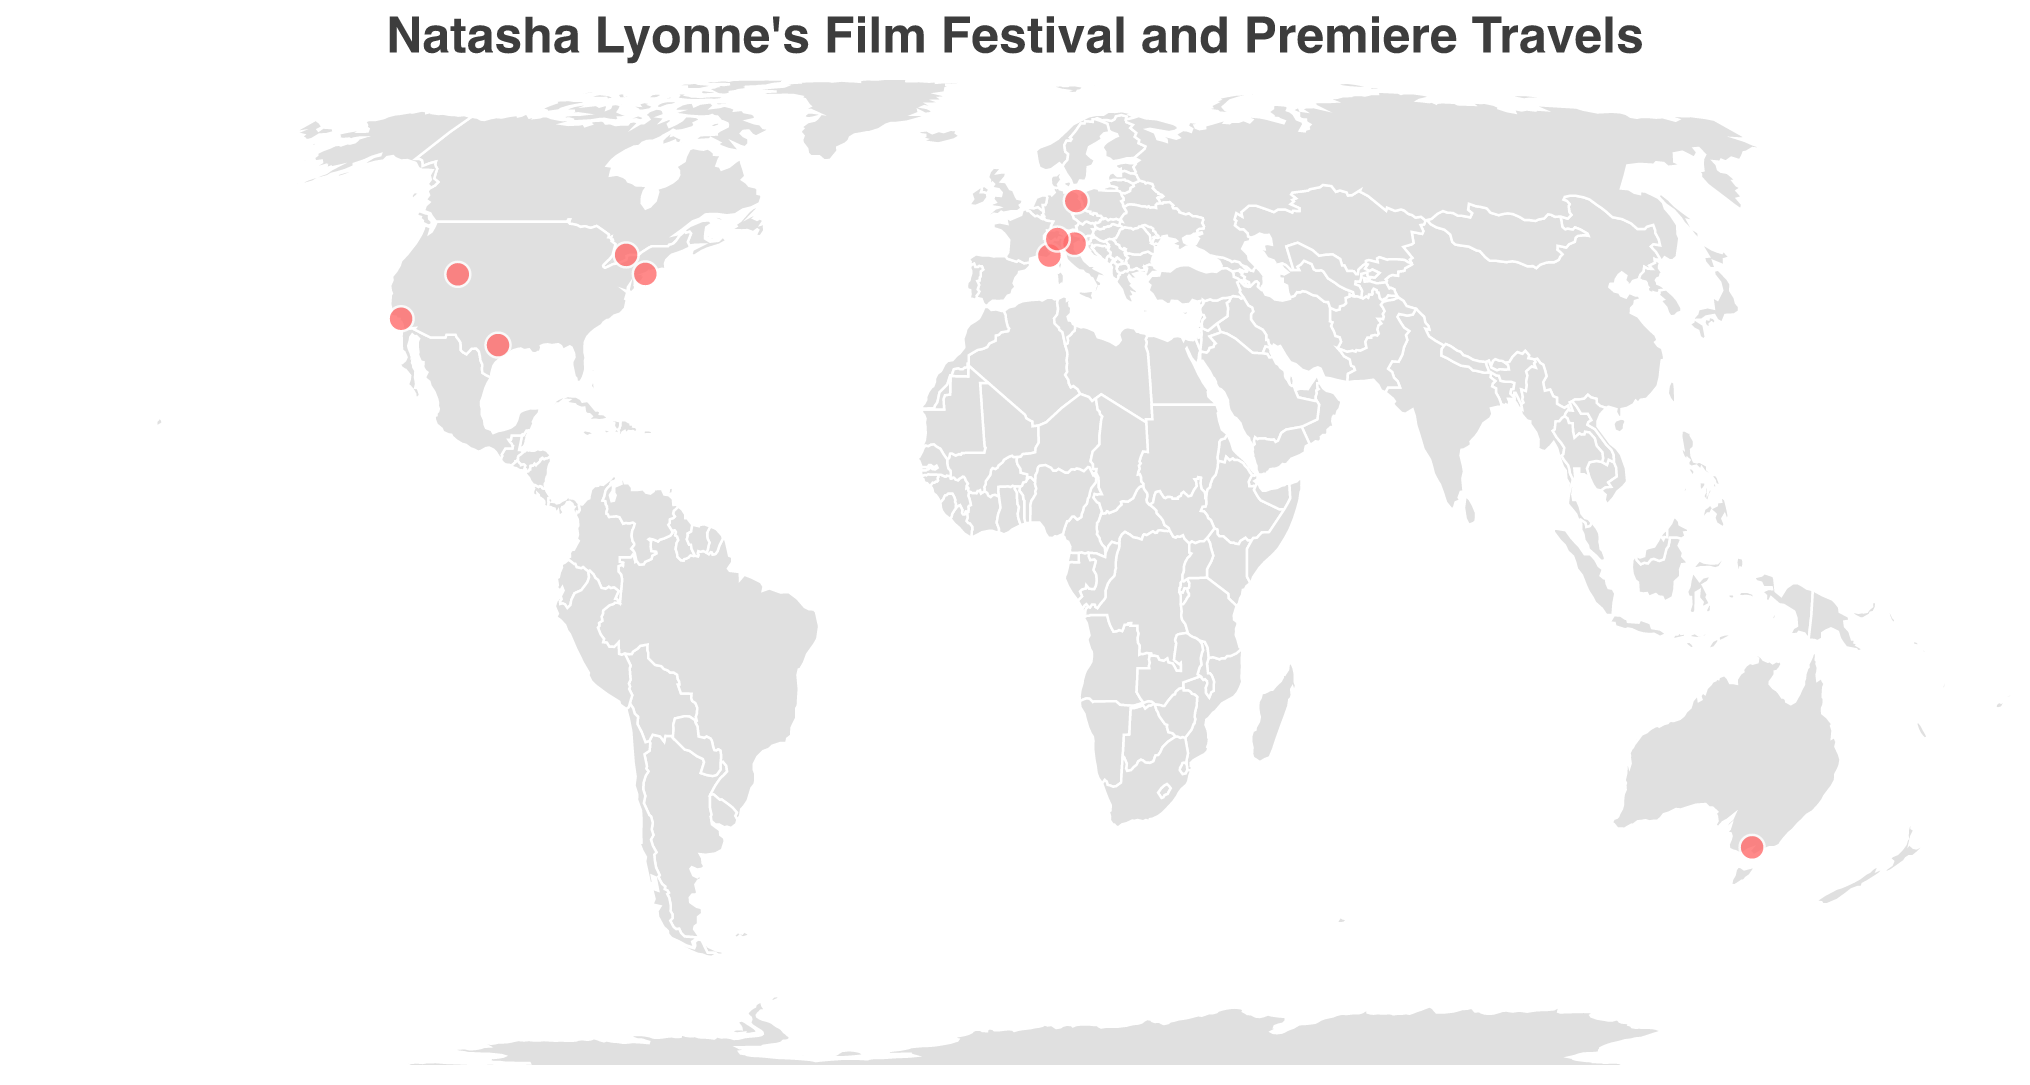What is the title of the figure? The title is displayed prominently on the top of the figure. It reads "Natasha Lyonne's Film Festival and Premiere Travels."
Answer: Natasha Lyonne's Film Festival and Premiere Travels How many events did Natasha Lyonne attend in Europe according to the data? By examining the geographic points and labels, we can see events in Cannes, Venice, Berlin, and Locarno, which are all in Europe.
Answer: 4 In which year did Natasha Lyonne travel the most, based on the visual data? By checking the frequencies of years next to the data points, it's visible that 2022 has three travel events (Austin, Locarno, and Los Angeles).
Answer: 2022 Which event took place the furthest south, and in which country? The point that appears furthest south on the geographic plot is for the Melbourne International Film Festival, located in Australia at approximately -37.8136 latitude.
Answer: Melbourne International Film Festival, Australia If we look only at the years 2021 and 2022, how many different countries did Natasha visit for events? In 2021, she visited the USA (New York) and Germany (Berlin). In 2022, she visited the USA (Austin and Los Angeles) and Switzerland (Locarno). Counting unique countries across these years: USA, Germany, and Switzerland.
Answer: 3 What is the average latitude of all the events Natasha Lyonne attended in 2019? Calculate the latitudes of Cannes (43.5528) and Toronto (43.6532), sum them up (43.5528 + 43.6532 = 87.206), and divide by 2 (87.206 / 2).
Answer: 43.603 Between which two adjacent years did the number of events Natasha attended increase the most? Comparing year by year; from 2019 to 2020 there's no increase (2 to 2); from 2020 to 2021, there's an increase (2 to 2); from 2021 to 2022 - there's an increase (2 to 3). The significant increase is between 2021 and 2022.
Answer: 2021 to 2022 